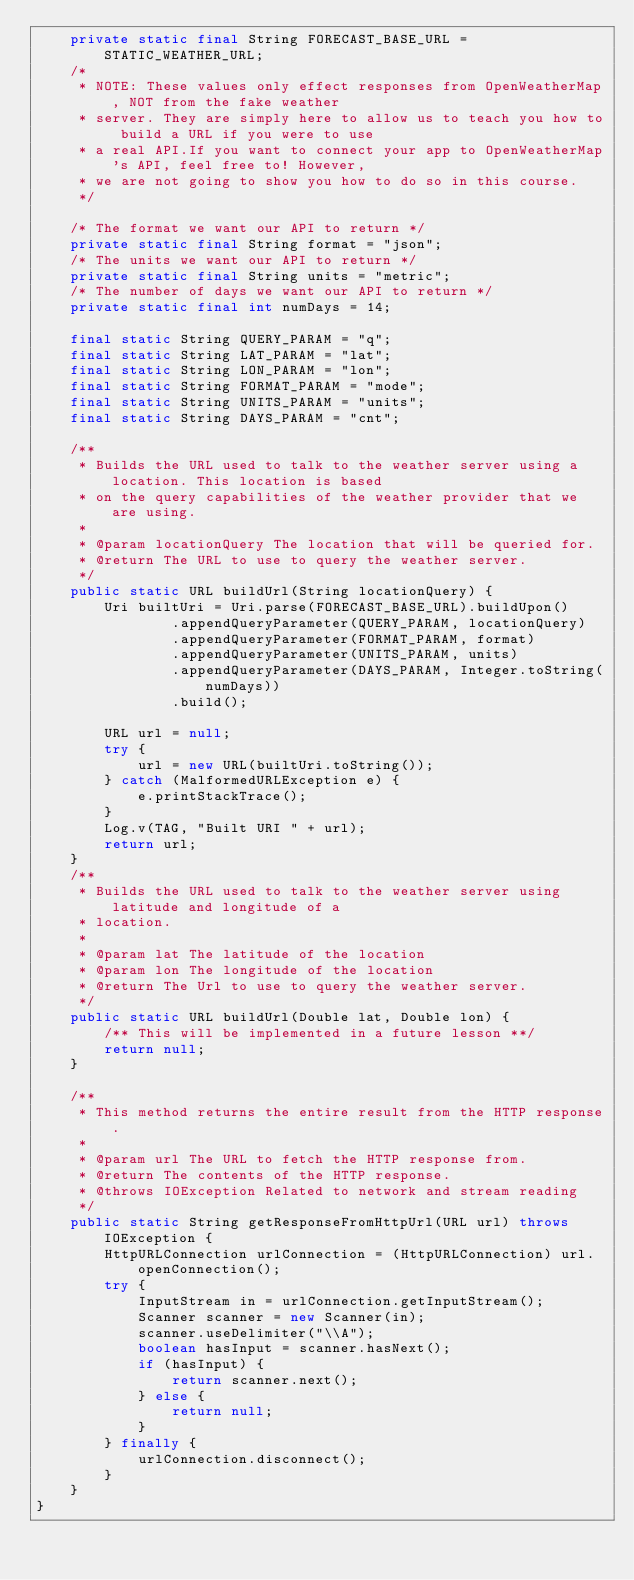<code> <loc_0><loc_0><loc_500><loc_500><_Java_>    private static final String FORECAST_BASE_URL = STATIC_WEATHER_URL;
    /*
     * NOTE: These values only effect responses from OpenWeatherMap, NOT from the fake weather
     * server. They are simply here to allow us to teach you how to build a URL if you were to use
     * a real API.If you want to connect your app to OpenWeatherMap's API, feel free to! However,
     * we are not going to show you how to do so in this course.
     */

    /* The format we want our API to return */
    private static final String format = "json";
    /* The units we want our API to return */
    private static final String units = "metric";
    /* The number of days we want our API to return */
    private static final int numDays = 14;

    final static String QUERY_PARAM = "q";
    final static String LAT_PARAM = "lat";
    final static String LON_PARAM = "lon";
    final static String FORMAT_PARAM = "mode";
    final static String UNITS_PARAM = "units";
    final static String DAYS_PARAM = "cnt";

    /**
     * Builds the URL used to talk to the weather server using a location. This location is based
     * on the query capabilities of the weather provider that we are using.
     *
     * @param locationQuery The location that will be queried for.
     * @return The URL to use to query the weather server.
     */
    public static URL buildUrl(String locationQuery) {
        Uri builtUri = Uri.parse(FORECAST_BASE_URL).buildUpon()
                .appendQueryParameter(QUERY_PARAM, locationQuery)
                .appendQueryParameter(FORMAT_PARAM, format)
                .appendQueryParameter(UNITS_PARAM, units)
                .appendQueryParameter(DAYS_PARAM, Integer.toString(numDays))
                .build();

        URL url = null;
        try {
            url = new URL(builtUri.toString());
        } catch (MalformedURLException e) {
            e.printStackTrace();
        }
        Log.v(TAG, "Built URI " + url);
        return url;
    }
    /**
     * Builds the URL used to talk to the weather server using latitude and longitude of a
     * location.
     *
     * @param lat The latitude of the location
     * @param lon The longitude of the location
     * @return The Url to use to query the weather server.
     */
    public static URL buildUrl(Double lat, Double lon) {
        /** This will be implemented in a future lesson **/
        return null;
    }

    /**
     * This method returns the entire result from the HTTP response.
     *
     * @param url The URL to fetch the HTTP response from.
     * @return The contents of the HTTP response.
     * @throws IOException Related to network and stream reading
     */
    public static String getResponseFromHttpUrl(URL url) throws IOException {
        HttpURLConnection urlConnection = (HttpURLConnection) url.openConnection();
        try {
            InputStream in = urlConnection.getInputStream();
            Scanner scanner = new Scanner(in);
            scanner.useDelimiter("\\A");
            boolean hasInput = scanner.hasNext();
            if (hasInput) {
                return scanner.next();
            } else {
                return null;
            }
        } finally {
            urlConnection.disconnect();
        }
    }
}</code> 